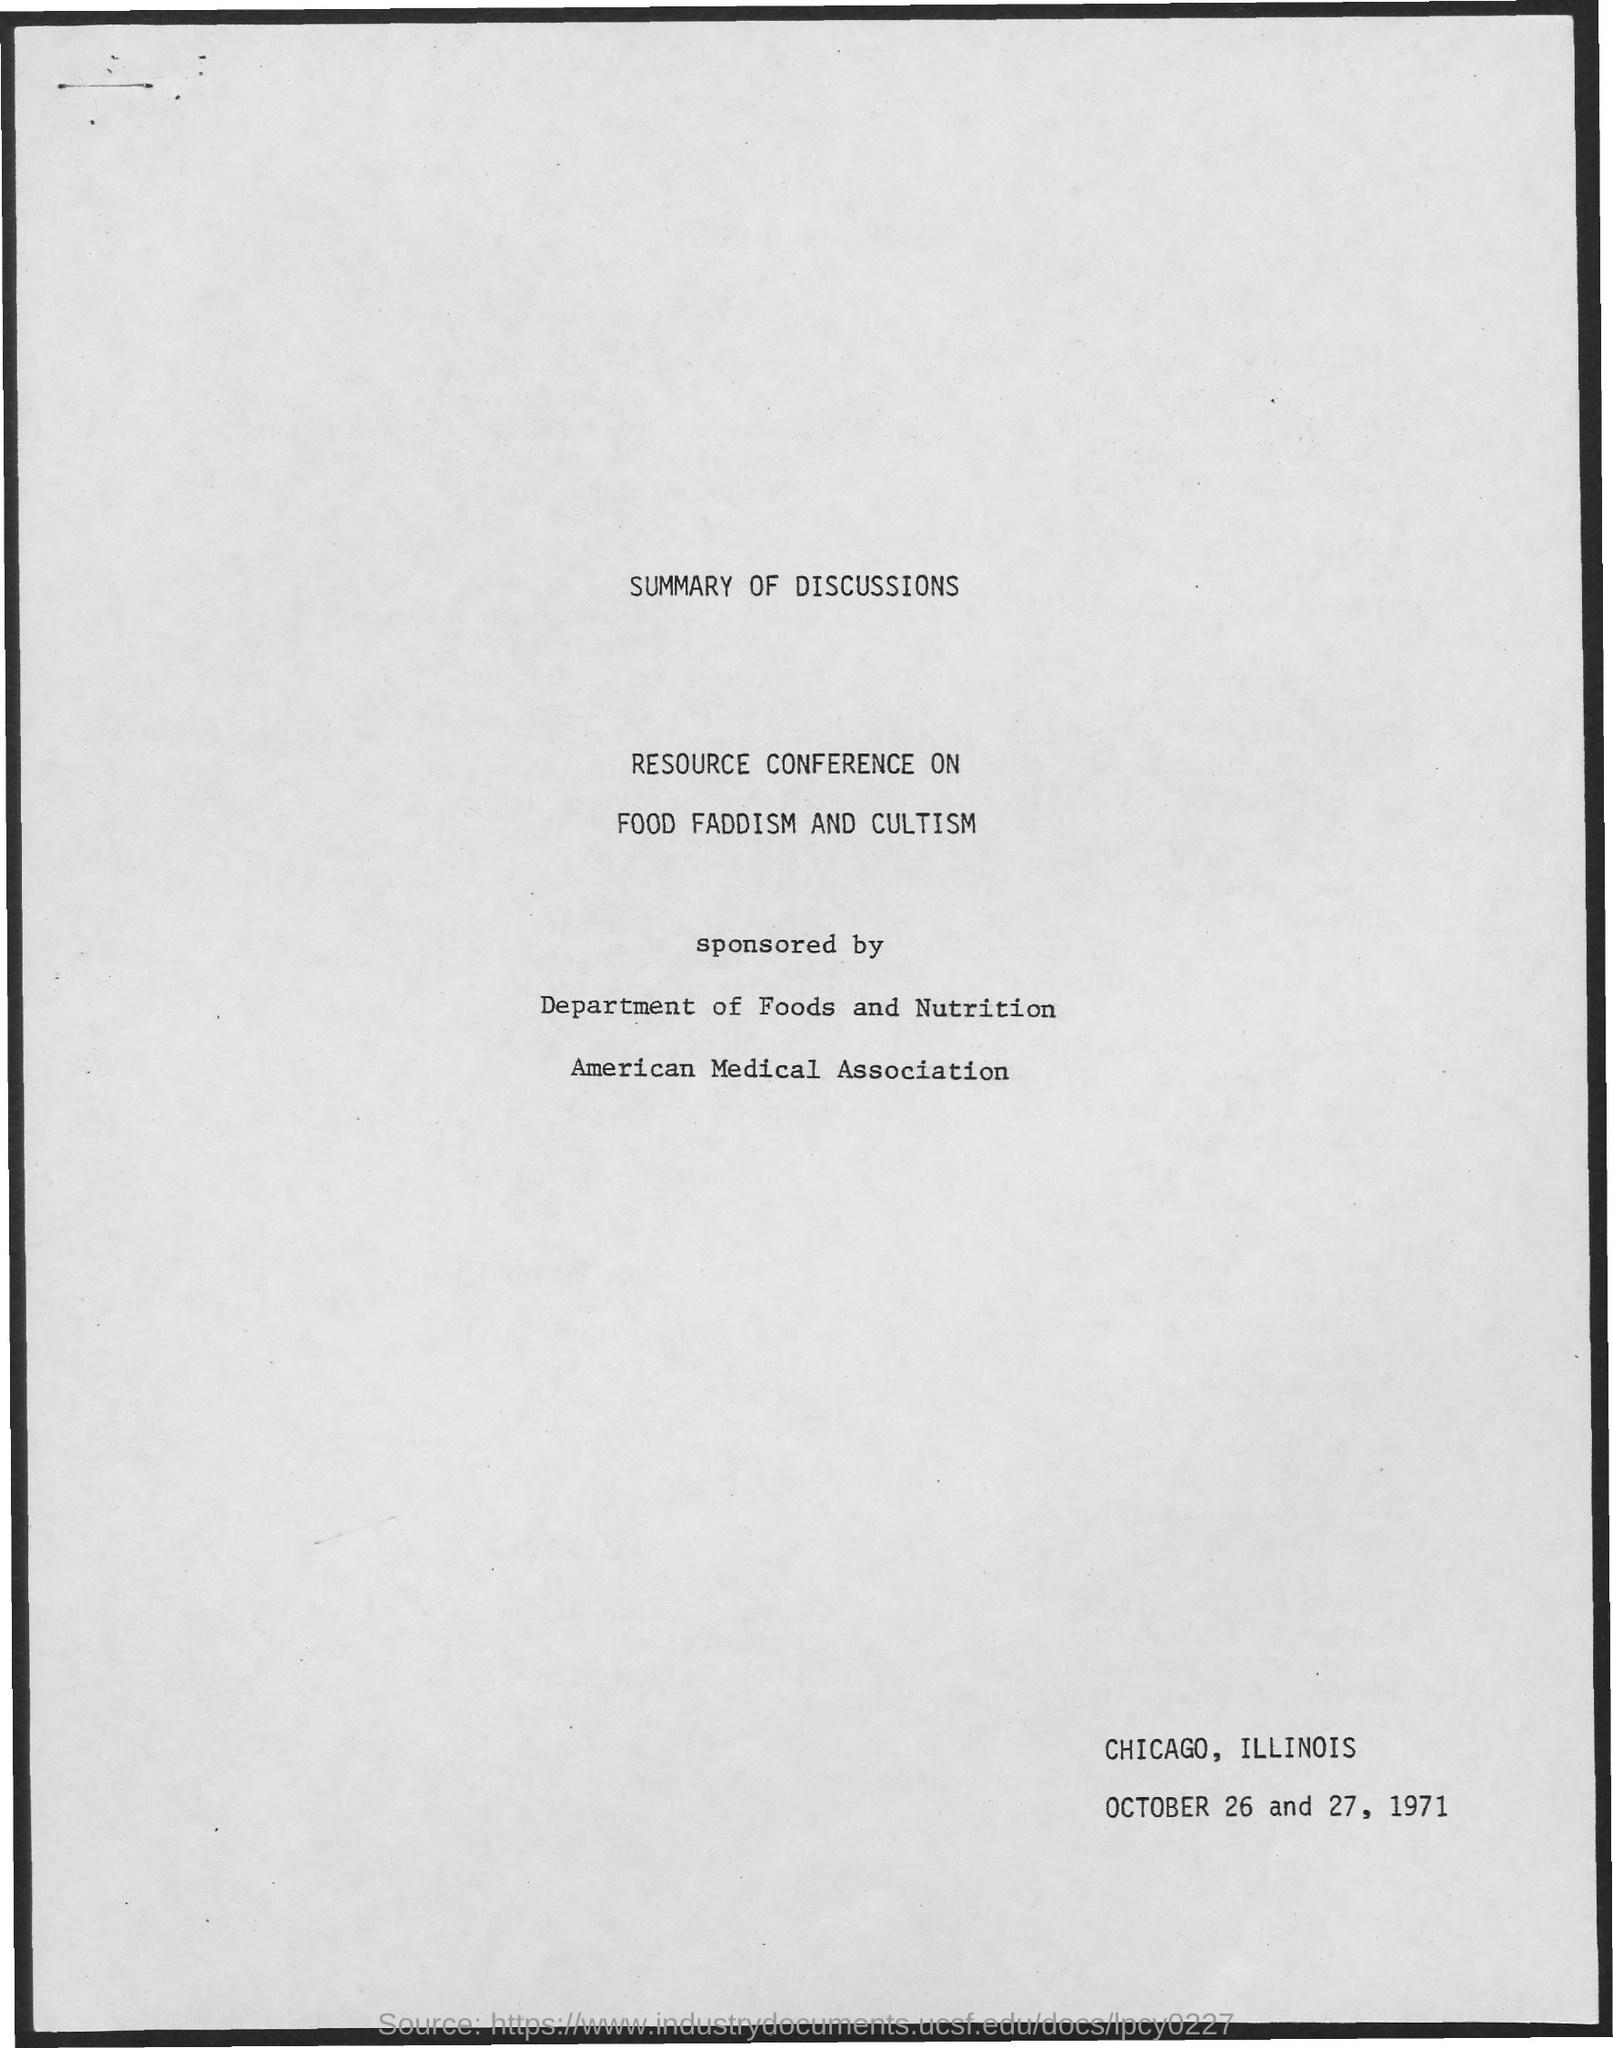Give some essential details in this illustration. The month mentioned in the document is October. The heading on the topmost document reads, "Summary of Discussions. 